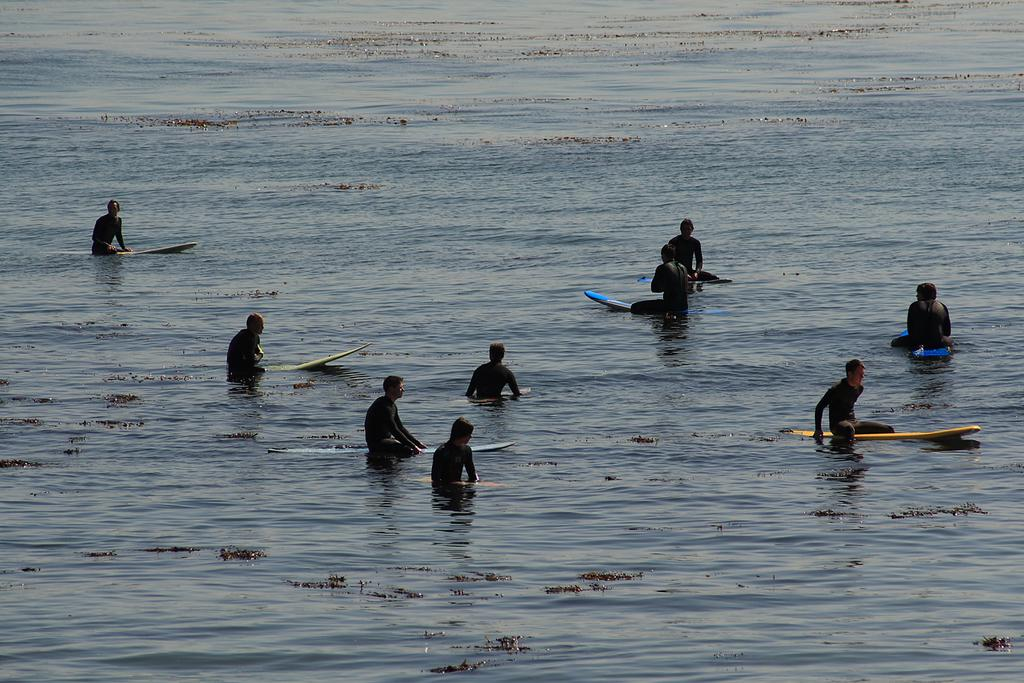Who is present in the image? There are people in the image. What are the people doing in the image? The people are floating on the water. How are the people floating on the water? The people are using surfboards. What type of hearing aid is the boy wearing in the image? There is no boy or hearing aid present in the image. What is the cause of the burn on the people's skin in the image? There is no burn or indication of any injury on the people's skin in the image. 